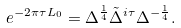<formula> <loc_0><loc_0><loc_500><loc_500>e ^ { - 2 \pi \tau L _ { 0 } } = \Delta ^ { \frac { 1 } { 4 } } \tilde { \Delta } ^ { i \tau } \Delta ^ { - \frac { 1 } { 4 } } .</formula> 